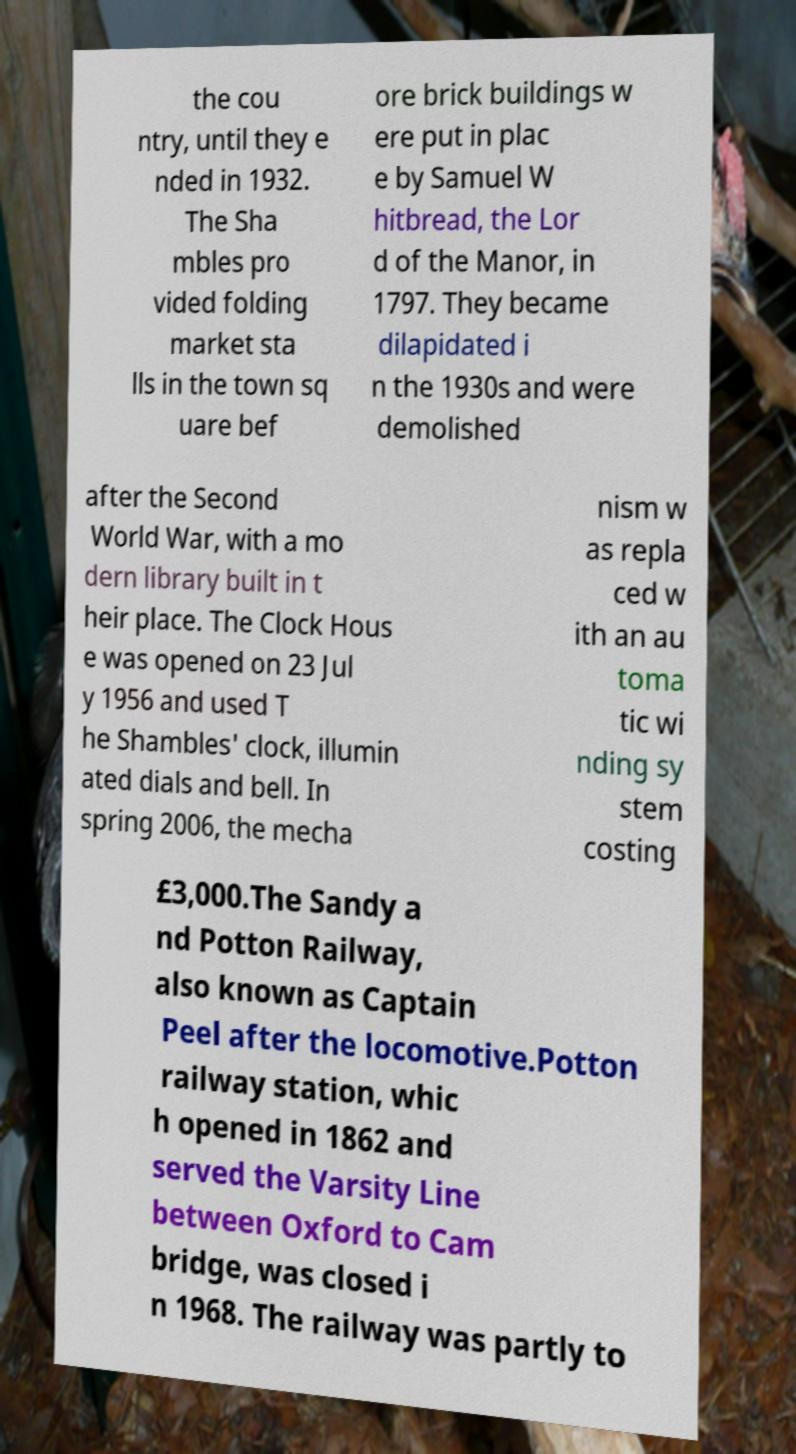I need the written content from this picture converted into text. Can you do that? the cou ntry, until they e nded in 1932. The Sha mbles pro vided folding market sta lls in the town sq uare bef ore brick buildings w ere put in plac e by Samuel W hitbread, the Lor d of the Manor, in 1797. They became dilapidated i n the 1930s and were demolished after the Second World War, with a mo dern library built in t heir place. The Clock Hous e was opened on 23 Jul y 1956 and used T he Shambles' clock, illumin ated dials and bell. In spring 2006, the mecha nism w as repla ced w ith an au toma tic wi nding sy stem costing £3,000.The Sandy a nd Potton Railway, also known as Captain Peel after the locomotive.Potton railway station, whic h opened in 1862 and served the Varsity Line between Oxford to Cam bridge, was closed i n 1968. The railway was partly to 